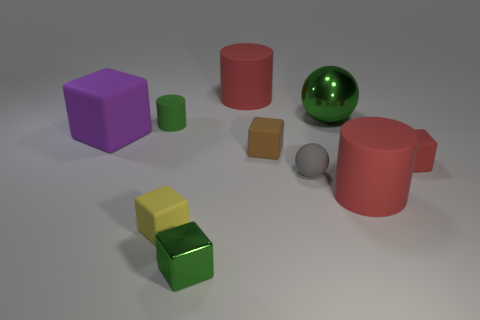There is a small gray matte object; are there any cylinders right of it?
Your response must be concise. Yes. There is a big matte cylinder that is to the right of the red rubber thing that is left of the green sphere; is there a green metallic object to the right of it?
Your answer should be very brief. No. There is a green shiny thing that is in front of the yellow matte cube; is its shape the same as the gray thing?
Offer a very short reply. No. The tiny cylinder that is the same material as the purple thing is what color?
Provide a short and direct response. Green. What number of tiny yellow balls have the same material as the red cube?
Keep it short and to the point. 0. What is the color of the tiny matte cylinder in front of the large cylinder that is left of the green shiny thing that is on the right side of the tiny gray matte ball?
Offer a very short reply. Green. Is the yellow thing the same size as the brown matte object?
Your response must be concise. Yes. How many objects are either red matte things left of the gray object or brown rubber cubes?
Your answer should be very brief. 2. Is the tiny brown object the same shape as the small yellow matte thing?
Provide a short and direct response. Yes. How many other things are there of the same size as the metal cube?
Ensure brevity in your answer.  5. 